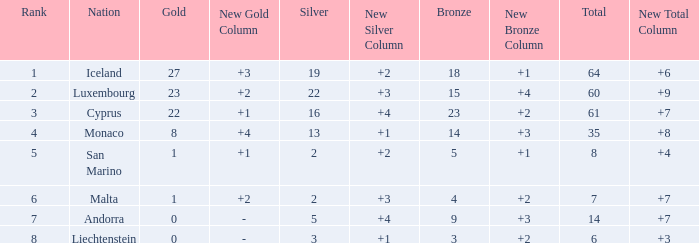How many bronzes for Iceland with over 2 silvers? 18.0. 